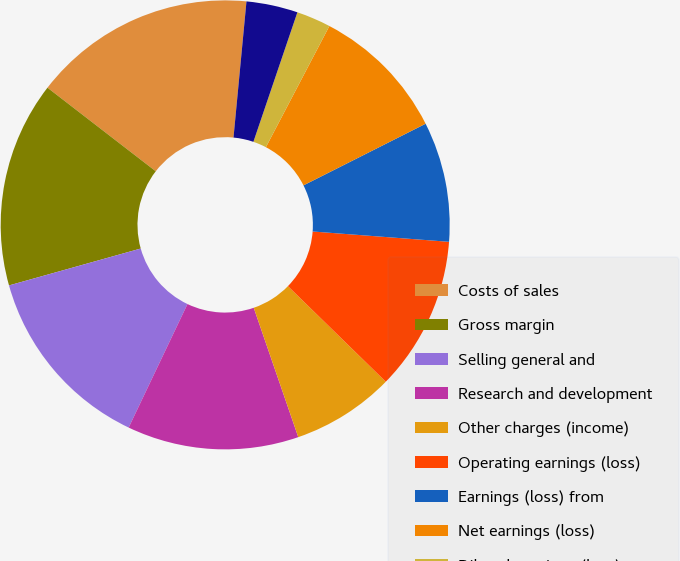<chart> <loc_0><loc_0><loc_500><loc_500><pie_chart><fcel>Costs of sales<fcel>Gross margin<fcel>Selling general and<fcel>Research and development<fcel>Other charges (income)<fcel>Operating earnings (loss)<fcel>Earnings (loss) from<fcel>Net earnings (loss)<fcel>Diluted earnings (loss) per<fcel>Basic earnings (loss) per<nl><fcel>16.05%<fcel>14.81%<fcel>13.58%<fcel>12.35%<fcel>7.41%<fcel>11.11%<fcel>8.64%<fcel>9.88%<fcel>2.47%<fcel>3.7%<nl></chart> 